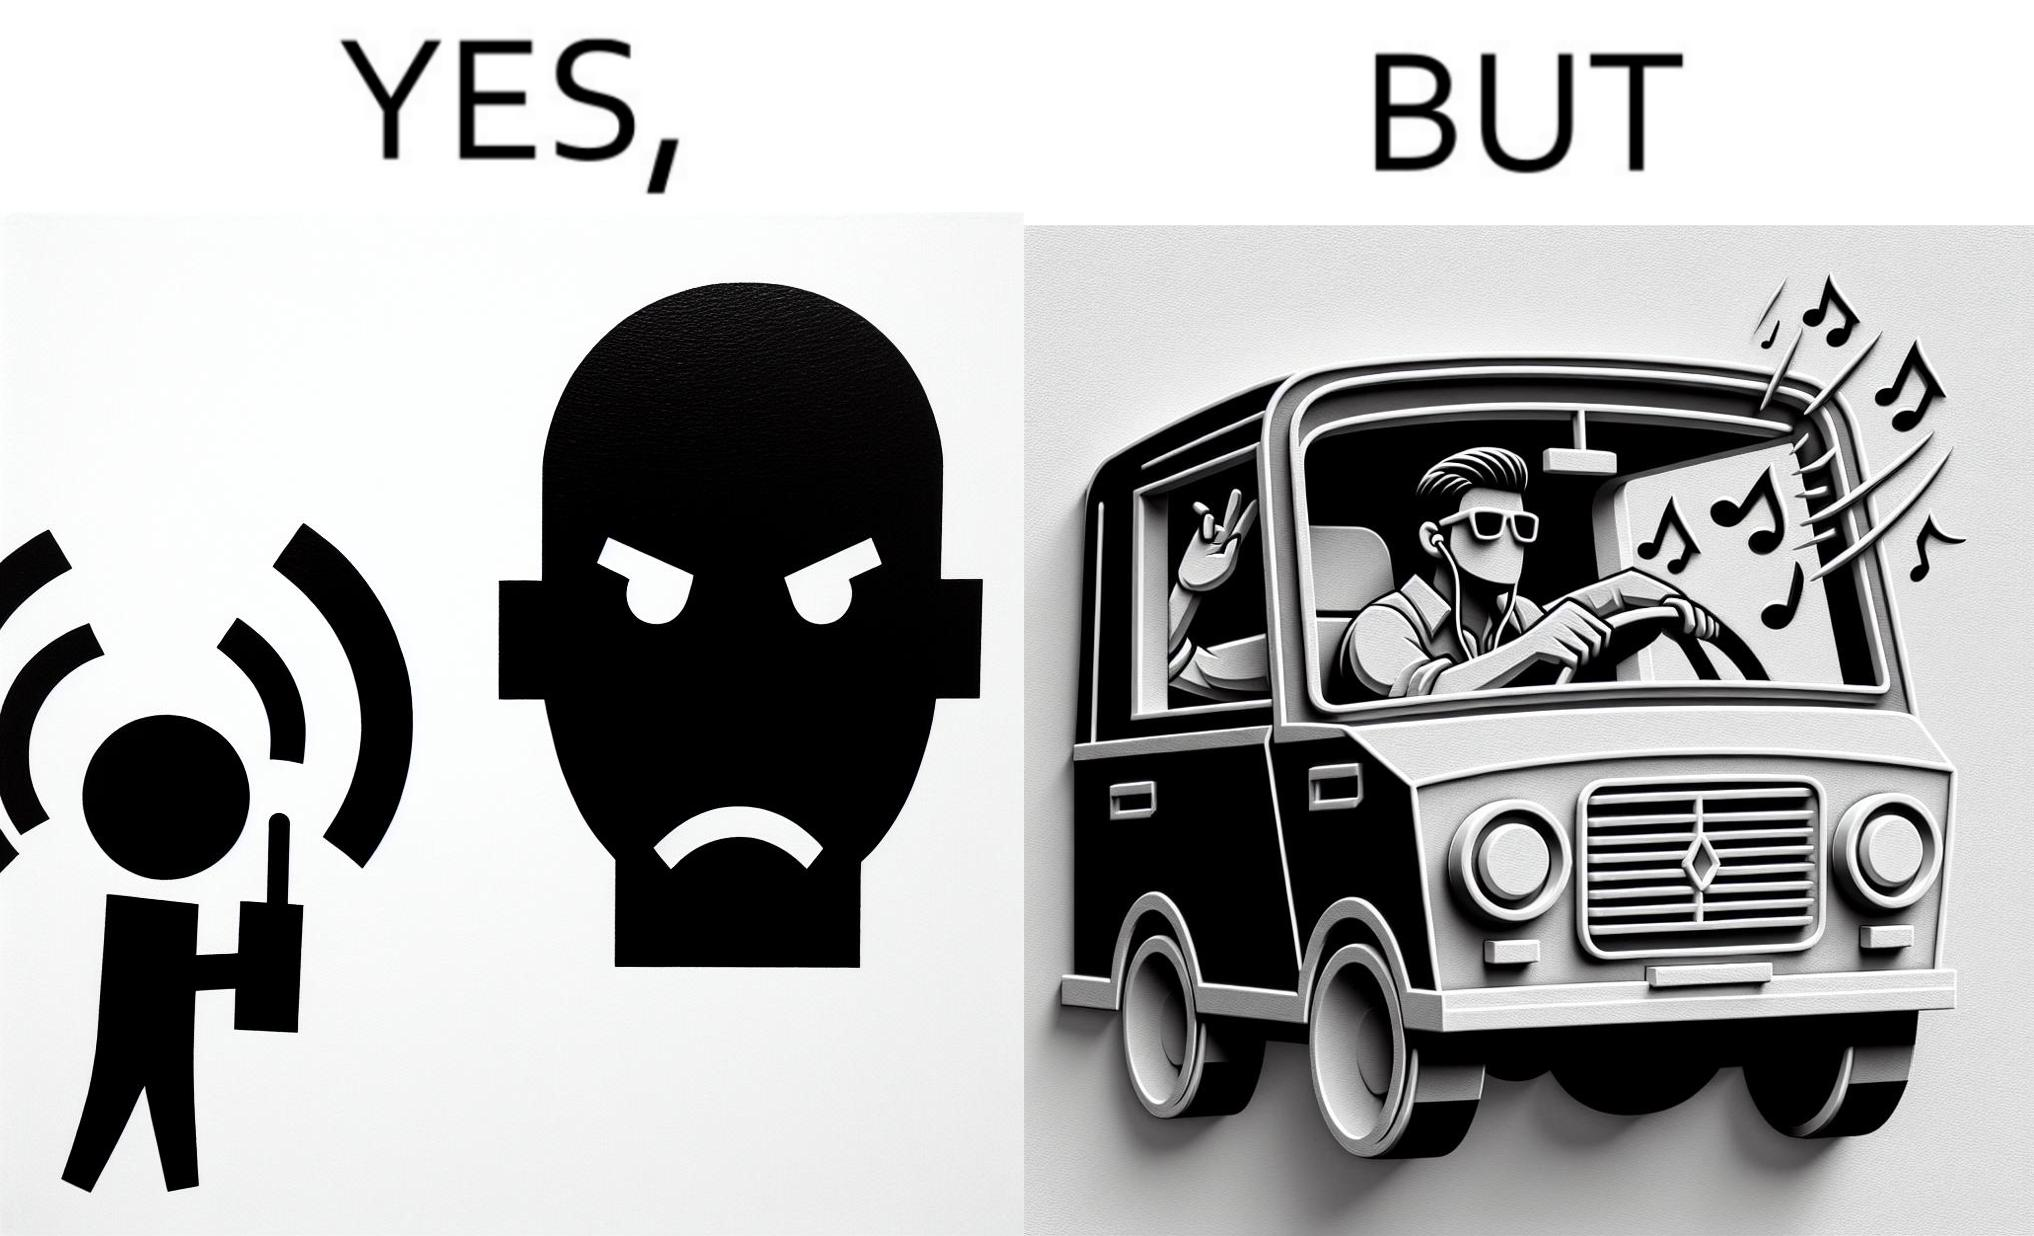Explain the humor or irony in this image. The image is funny because while the man does not like the boy playing music loudly on his phone, the man himself is okay with doing the same thing with his car and playing loud music in the car with the sound coming out of the car. 